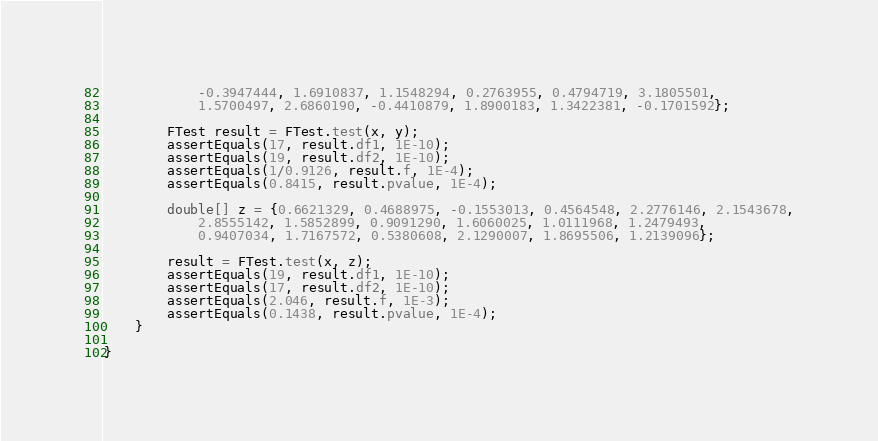<code> <loc_0><loc_0><loc_500><loc_500><_Java_>            -0.3947444, 1.6910837, 1.1548294, 0.2763955, 0.4794719, 3.1805501,
            1.5700497, 2.6860190, -0.4410879, 1.8900183, 1.3422381, -0.1701592};

        FTest result = FTest.test(x, y);
        assertEquals(17, result.df1, 1E-10);
        assertEquals(19, result.df2, 1E-10);
        assertEquals(1/0.9126, result.f, 1E-4);
        assertEquals(0.8415, result.pvalue, 1E-4);

        double[] z = {0.6621329, 0.4688975, -0.1553013, 0.4564548, 2.2776146, 2.1543678,
            2.8555142, 1.5852899, 0.9091290, 1.6060025, 1.0111968, 1.2479493,
            0.9407034, 1.7167572, 0.5380608, 2.1290007, 1.8695506, 1.2139096};

        result = FTest.test(x, z);
        assertEquals(19, result.df1, 1E-10);
        assertEquals(17, result.df2, 1E-10);
        assertEquals(2.046, result.f, 1E-3);
        assertEquals(0.1438, result.pvalue, 1E-4);
    }

}</code> 